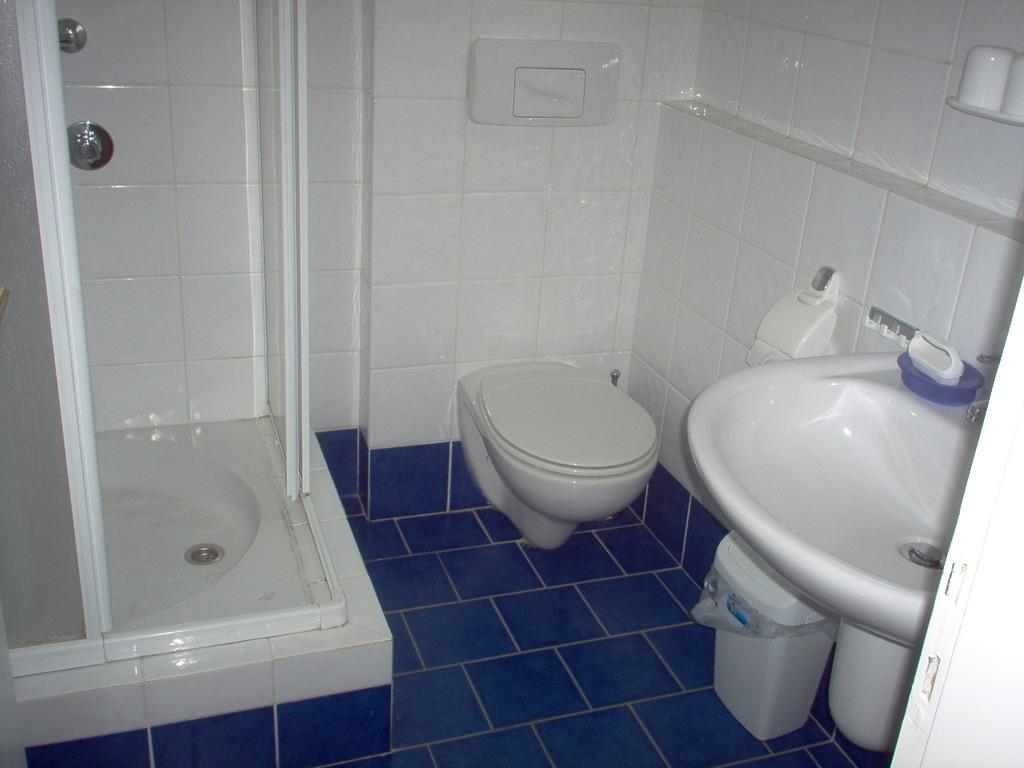What is the primary object in the image? There is a toilet seat in the image. What other objects related to personal hygiene can be seen in the image? There are sinks in the image. Is there a place to dispose of waste in the image? Yes, there is a dustbin in the image. What can be seen in the background of the image? There is a wall in the background of the image. Can you describe any other objects present in the image? There are some objects in the image, but their specific details are not mentioned in the provided facts. What type of coil is used to heat the water in the image? There is no coil or water heater present in the image; it features a toilet seat, sinks, a dustbin, and a wall. What is the texture of the judge's robe in the image? There is no judge or robe present in the image; it only contains objects related to personal hygiene and a wall in the background. 